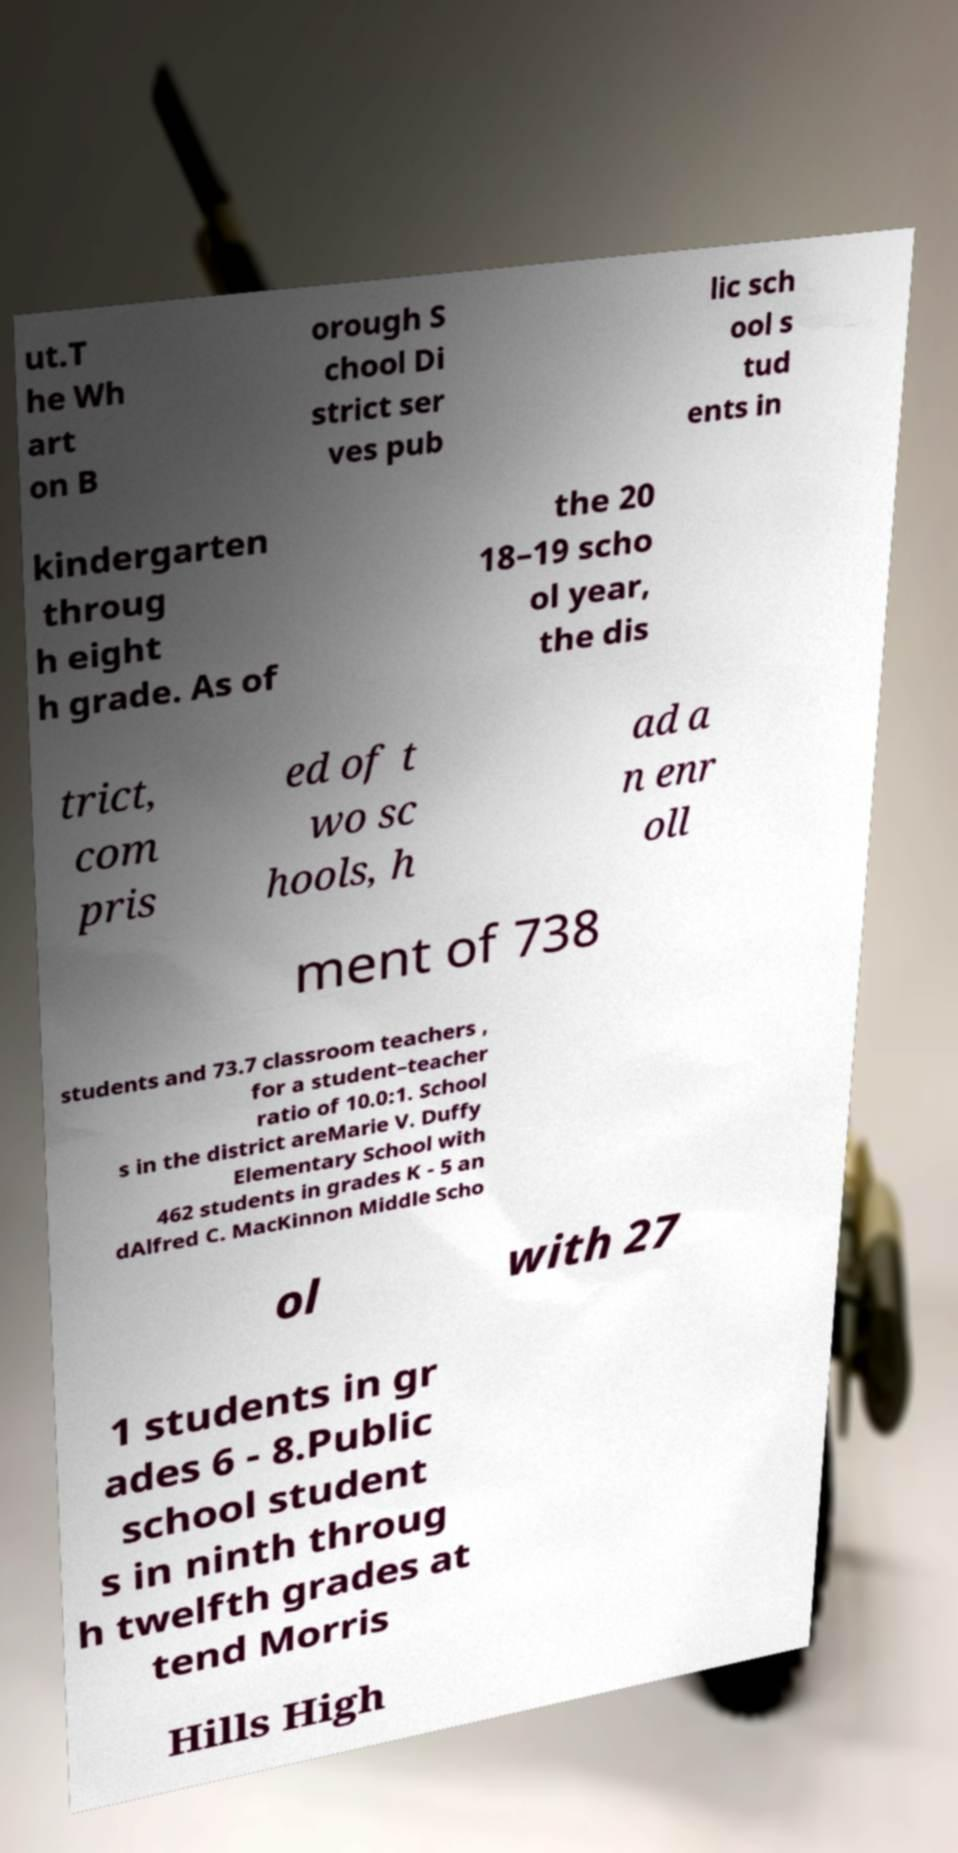Can you accurately transcribe the text from the provided image for me? ut.T he Wh art on B orough S chool Di strict ser ves pub lic sch ool s tud ents in kindergarten throug h eight h grade. As of the 20 18–19 scho ol year, the dis trict, com pris ed of t wo sc hools, h ad a n enr oll ment of 738 students and 73.7 classroom teachers , for a student–teacher ratio of 10.0:1. School s in the district areMarie V. Duffy Elementary School with 462 students in grades K - 5 an dAlfred C. MacKinnon Middle Scho ol with 27 1 students in gr ades 6 - 8.Public school student s in ninth throug h twelfth grades at tend Morris Hills High 